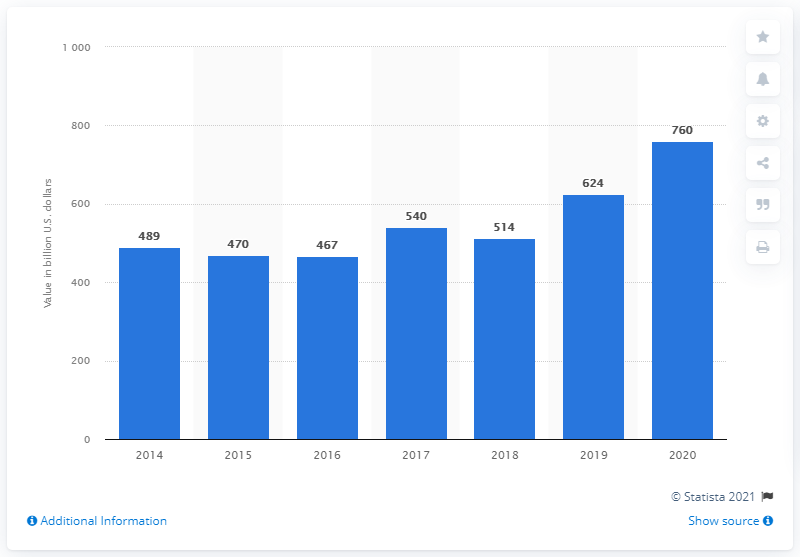Point out several critical features in this image. In 2020, the value of JPMorgan Chase's retail customer assets was approximately 760 billion dollars. 